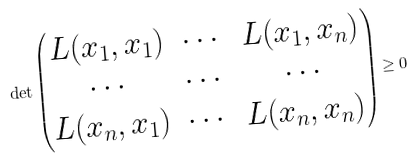Convert formula to latex. <formula><loc_0><loc_0><loc_500><loc_500>\det \begin{pmatrix} L ( x _ { 1 } , x _ { 1 } ) & \cdots & L ( x _ { 1 } , x _ { n } ) \\ \cdots & \cdots & \cdots \\ L ( x _ { n } , x _ { 1 } ) & \cdots & L ( x _ { n } , x _ { n } ) \end{pmatrix} \geq 0</formula> 